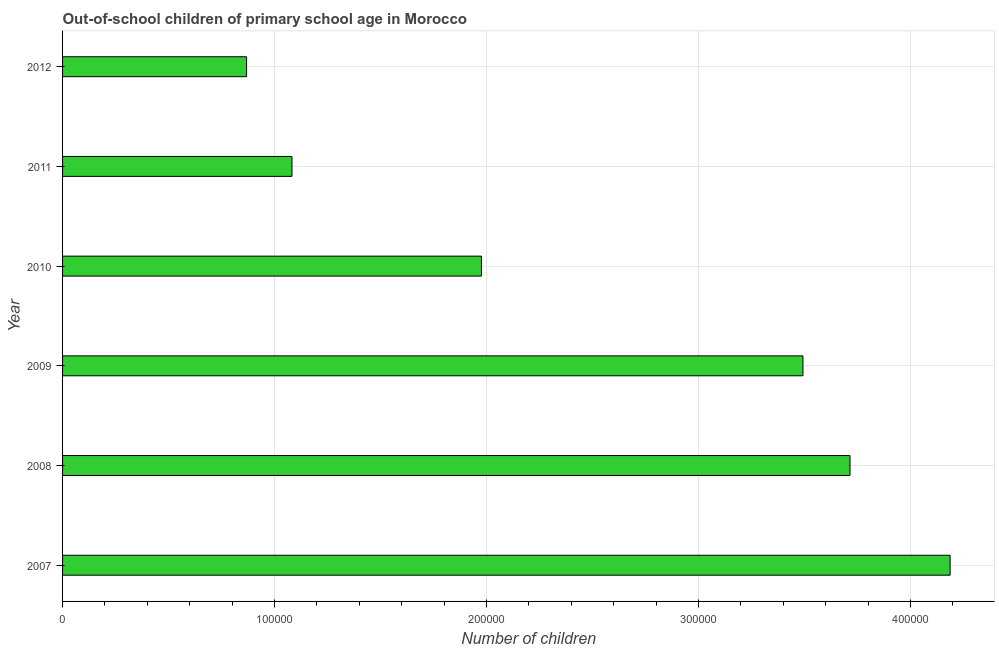Does the graph contain any zero values?
Keep it short and to the point. No. What is the title of the graph?
Offer a terse response. Out-of-school children of primary school age in Morocco. What is the label or title of the X-axis?
Your response must be concise. Number of children. What is the number of out-of-school children in 2010?
Your answer should be compact. 1.98e+05. Across all years, what is the maximum number of out-of-school children?
Give a very brief answer. 4.19e+05. Across all years, what is the minimum number of out-of-school children?
Ensure brevity in your answer.  8.68e+04. In which year was the number of out-of-school children maximum?
Offer a terse response. 2007. In which year was the number of out-of-school children minimum?
Provide a succinct answer. 2012. What is the sum of the number of out-of-school children?
Provide a short and direct response. 1.53e+06. What is the difference between the number of out-of-school children in 2010 and 2012?
Keep it short and to the point. 1.11e+05. What is the average number of out-of-school children per year?
Keep it short and to the point. 2.55e+05. What is the median number of out-of-school children?
Provide a short and direct response. 2.73e+05. In how many years, is the number of out-of-school children greater than 140000 ?
Your answer should be very brief. 4. What is the ratio of the number of out-of-school children in 2008 to that in 2012?
Ensure brevity in your answer.  4.28. Is the number of out-of-school children in 2009 less than that in 2010?
Provide a short and direct response. No. Is the difference between the number of out-of-school children in 2007 and 2011 greater than the difference between any two years?
Offer a terse response. No. What is the difference between the highest and the second highest number of out-of-school children?
Your answer should be very brief. 4.72e+04. What is the difference between the highest and the lowest number of out-of-school children?
Offer a terse response. 3.32e+05. In how many years, is the number of out-of-school children greater than the average number of out-of-school children taken over all years?
Provide a succinct answer. 3. How many bars are there?
Offer a very short reply. 6. Are all the bars in the graph horizontal?
Provide a succinct answer. Yes. How many years are there in the graph?
Make the answer very short. 6. What is the Number of children in 2007?
Your answer should be compact. 4.19e+05. What is the Number of children of 2008?
Your response must be concise. 3.71e+05. What is the Number of children in 2009?
Keep it short and to the point. 3.49e+05. What is the Number of children of 2010?
Ensure brevity in your answer.  1.98e+05. What is the Number of children in 2011?
Provide a succinct answer. 1.08e+05. What is the Number of children in 2012?
Provide a short and direct response. 8.68e+04. What is the difference between the Number of children in 2007 and 2008?
Provide a succinct answer. 4.72e+04. What is the difference between the Number of children in 2007 and 2009?
Your answer should be very brief. 6.94e+04. What is the difference between the Number of children in 2007 and 2010?
Provide a short and direct response. 2.21e+05. What is the difference between the Number of children in 2007 and 2011?
Offer a terse response. 3.10e+05. What is the difference between the Number of children in 2007 and 2012?
Give a very brief answer. 3.32e+05. What is the difference between the Number of children in 2008 and 2009?
Your answer should be very brief. 2.22e+04. What is the difference between the Number of children in 2008 and 2010?
Your answer should be very brief. 1.74e+05. What is the difference between the Number of children in 2008 and 2011?
Your response must be concise. 2.63e+05. What is the difference between the Number of children in 2008 and 2012?
Give a very brief answer. 2.85e+05. What is the difference between the Number of children in 2009 and 2010?
Your response must be concise. 1.52e+05. What is the difference between the Number of children in 2009 and 2011?
Your answer should be compact. 2.41e+05. What is the difference between the Number of children in 2009 and 2012?
Your response must be concise. 2.62e+05. What is the difference between the Number of children in 2010 and 2011?
Provide a succinct answer. 8.94e+04. What is the difference between the Number of children in 2010 and 2012?
Your response must be concise. 1.11e+05. What is the difference between the Number of children in 2011 and 2012?
Give a very brief answer. 2.14e+04. What is the ratio of the Number of children in 2007 to that in 2008?
Keep it short and to the point. 1.13. What is the ratio of the Number of children in 2007 to that in 2009?
Your answer should be very brief. 1.2. What is the ratio of the Number of children in 2007 to that in 2010?
Offer a terse response. 2.12. What is the ratio of the Number of children in 2007 to that in 2011?
Your answer should be very brief. 3.87. What is the ratio of the Number of children in 2007 to that in 2012?
Offer a very short reply. 4.82. What is the ratio of the Number of children in 2008 to that in 2009?
Your answer should be compact. 1.06. What is the ratio of the Number of children in 2008 to that in 2010?
Give a very brief answer. 1.88. What is the ratio of the Number of children in 2008 to that in 2011?
Your answer should be compact. 3.43. What is the ratio of the Number of children in 2008 to that in 2012?
Provide a short and direct response. 4.28. What is the ratio of the Number of children in 2009 to that in 2010?
Give a very brief answer. 1.77. What is the ratio of the Number of children in 2009 to that in 2011?
Keep it short and to the point. 3.23. What is the ratio of the Number of children in 2009 to that in 2012?
Give a very brief answer. 4.02. What is the ratio of the Number of children in 2010 to that in 2011?
Your answer should be compact. 1.83. What is the ratio of the Number of children in 2010 to that in 2012?
Ensure brevity in your answer.  2.28. What is the ratio of the Number of children in 2011 to that in 2012?
Make the answer very short. 1.25. 